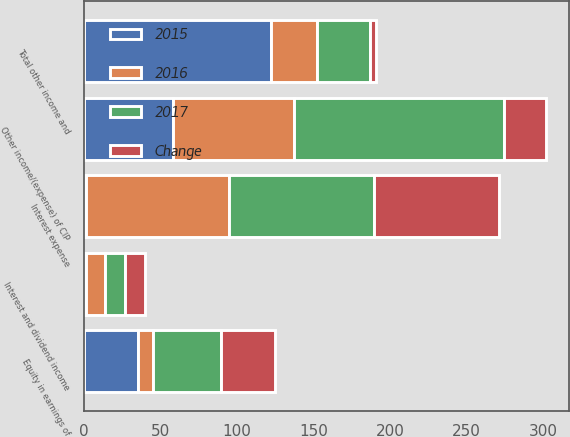Convert chart. <chart><loc_0><loc_0><loc_500><loc_500><stacked_bar_chart><ecel><fcel>Equity in earnings of<fcel>Interest and dividend income<fcel>Interest expense<fcel>Other income/(expense) of CIP<fcel>Total other income and<nl><fcel>2017<fcel>44.7<fcel>13.4<fcel>94.8<fcel>137.3<fcel>35.1<nl><fcel>2016<fcel>9.3<fcel>12.2<fcel>93.4<fcel>79.2<fcel>30.2<nl><fcel>Change<fcel>35.1<fcel>13<fcel>81.7<fcel>27.1<fcel>3.7<nl><fcel>2015<fcel>35.4<fcel>1.2<fcel>1.4<fcel>58.1<fcel>121.9<nl></chart> 